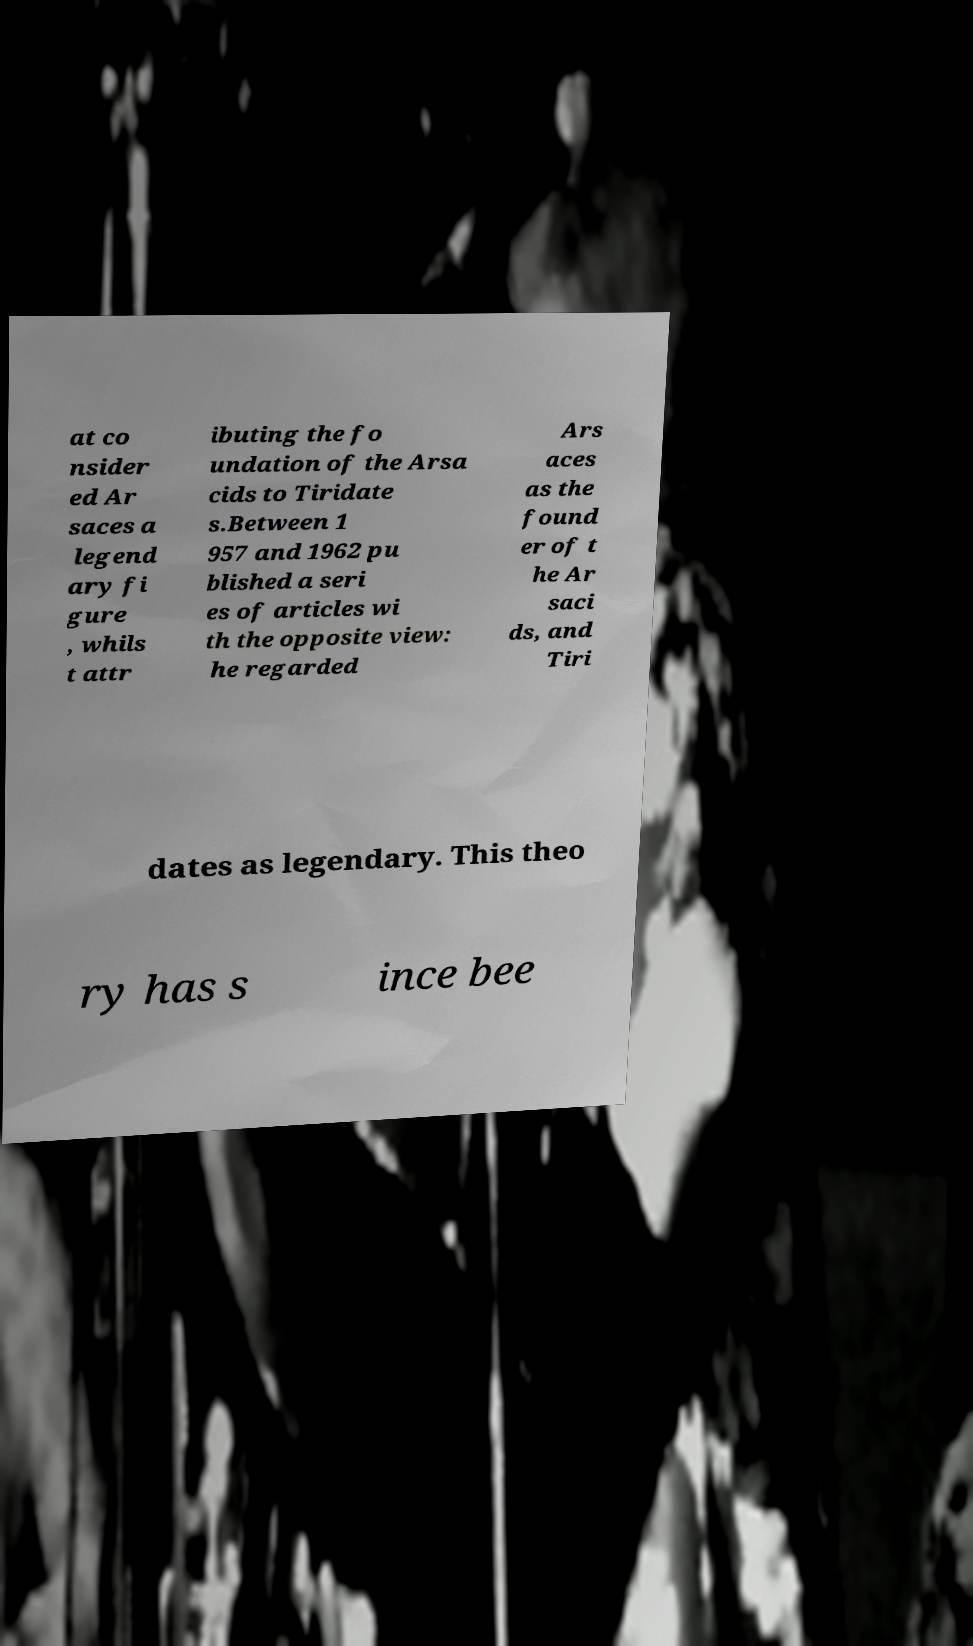There's text embedded in this image that I need extracted. Can you transcribe it verbatim? at co nsider ed Ar saces a legend ary fi gure , whils t attr ibuting the fo undation of the Arsa cids to Tiridate s.Between 1 957 and 1962 pu blished a seri es of articles wi th the opposite view: he regarded Ars aces as the found er of t he Ar saci ds, and Tiri dates as legendary. This theo ry has s ince bee 